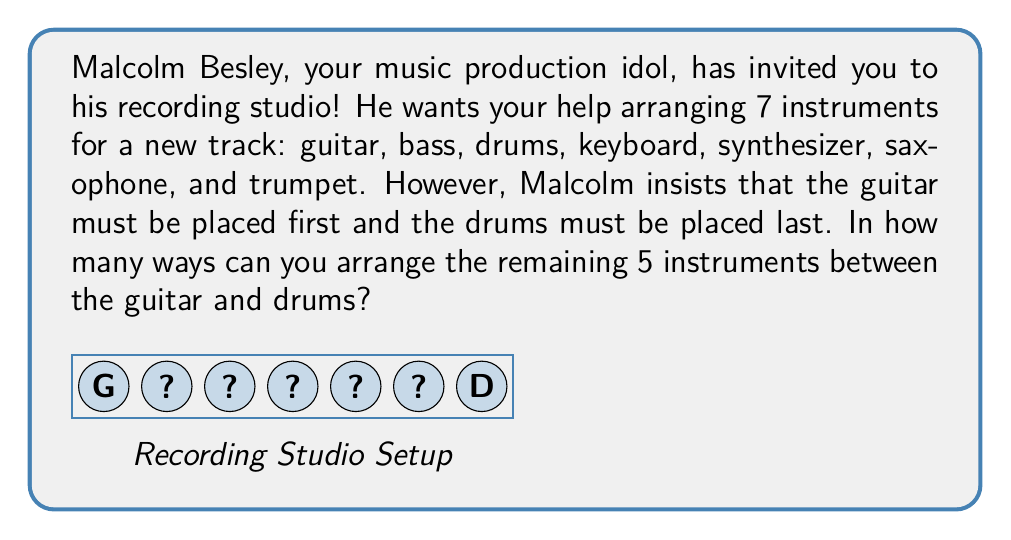Show me your answer to this math problem. Let's approach this step-by-step:

1) We have 7 instruments in total, but the positions of the guitar (first) and drums (last) are fixed. This leaves us with 5 instruments to arrange in the middle 5 positions.

2) This is a permutation problem. We need to calculate how many ways we can arrange 5 distinct objects (the remaining instruments) in 5 positions.

3) The formula for permutations of n distinct objects is:

   $$P(n) = n!$$

   Where $n!$ represents the factorial of $n$.

4) In this case, $n = 5$, so we need to calculate $5!$

5) Let's expand this:
   
   $$5! = 5 \times 4 \times 3 \times 2 \times 1 = 120$$

Therefore, there are 120 ways to arrange the 5 remaining instruments between the guitar and drums.
Answer: $120$ 